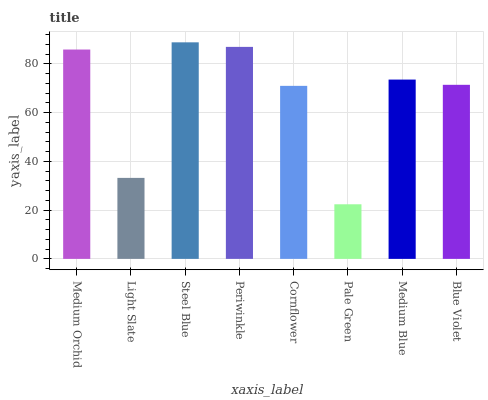Is Light Slate the minimum?
Answer yes or no. No. Is Light Slate the maximum?
Answer yes or no. No. Is Medium Orchid greater than Light Slate?
Answer yes or no. Yes. Is Light Slate less than Medium Orchid?
Answer yes or no. Yes. Is Light Slate greater than Medium Orchid?
Answer yes or no. No. Is Medium Orchid less than Light Slate?
Answer yes or no. No. Is Medium Blue the high median?
Answer yes or no. Yes. Is Blue Violet the low median?
Answer yes or no. Yes. Is Periwinkle the high median?
Answer yes or no. No. Is Medium Blue the low median?
Answer yes or no. No. 